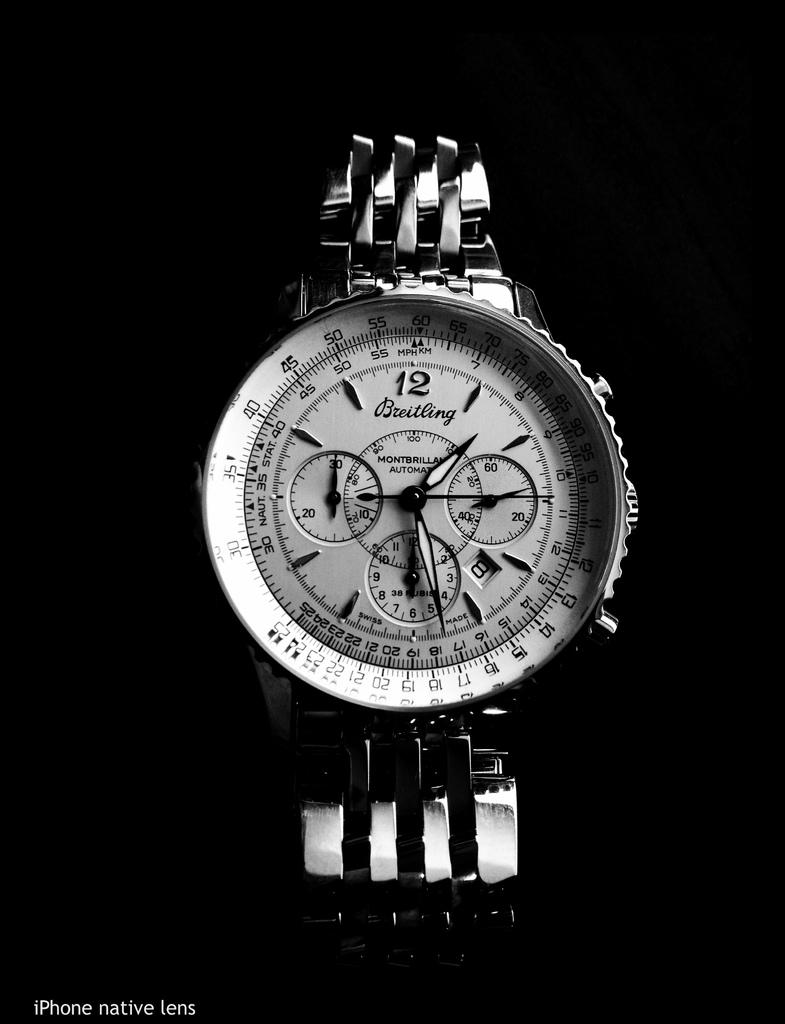<image>
Offer a succinct explanation of the picture presented. A watch with the time 1:28 on its face. 